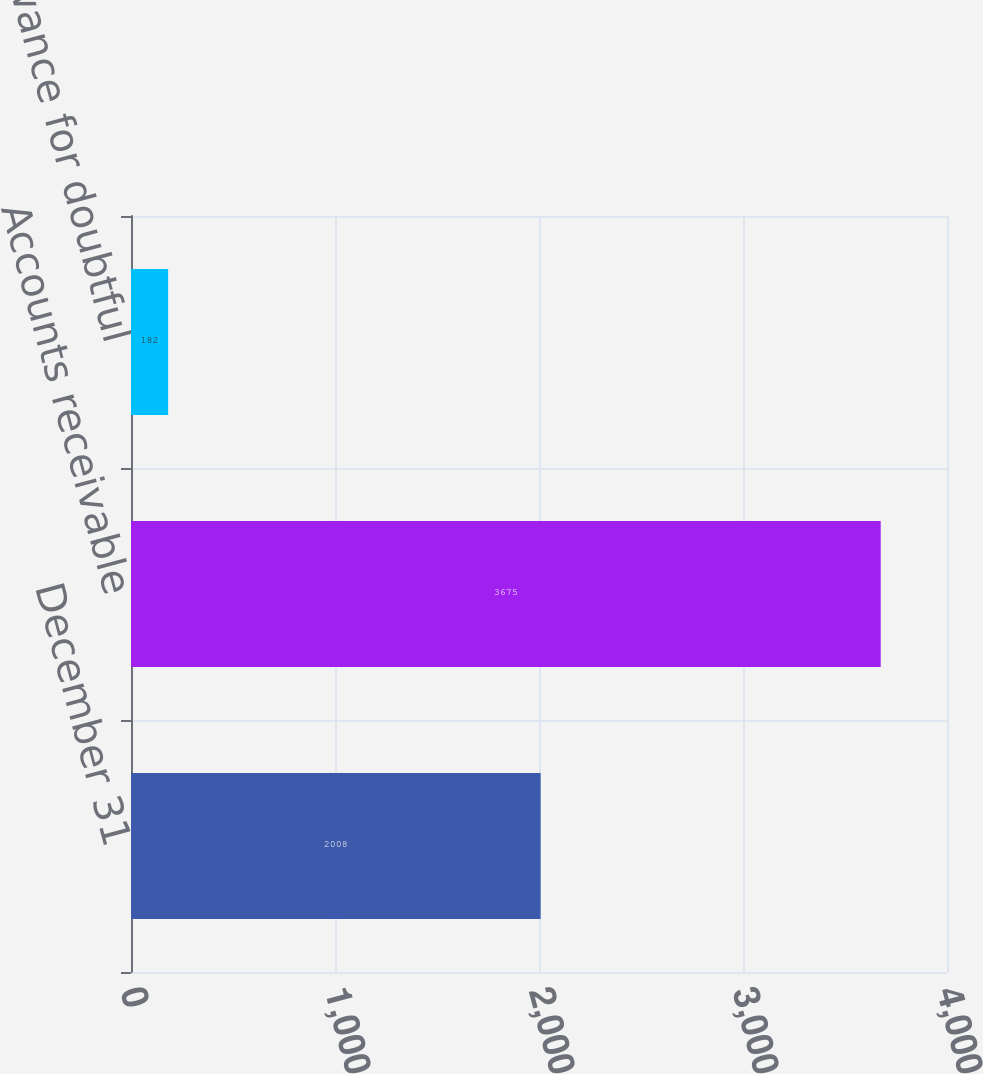Convert chart. <chart><loc_0><loc_0><loc_500><loc_500><bar_chart><fcel>December 31<fcel>Accounts receivable<fcel>Less allowance for doubtful<nl><fcel>2008<fcel>3675<fcel>182<nl></chart> 